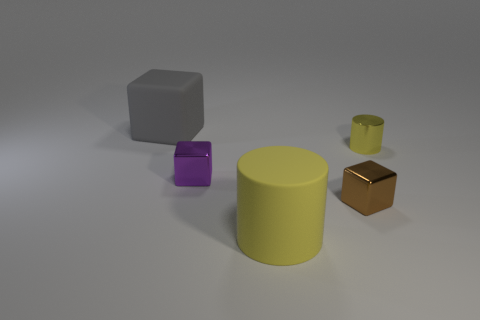If this image were part of an educational material, what lesson might it be teaching? This image could be part of a lesson on geometry and shapes, color theory, or perhaps even a tutorial on 3D rendering and material properties. 